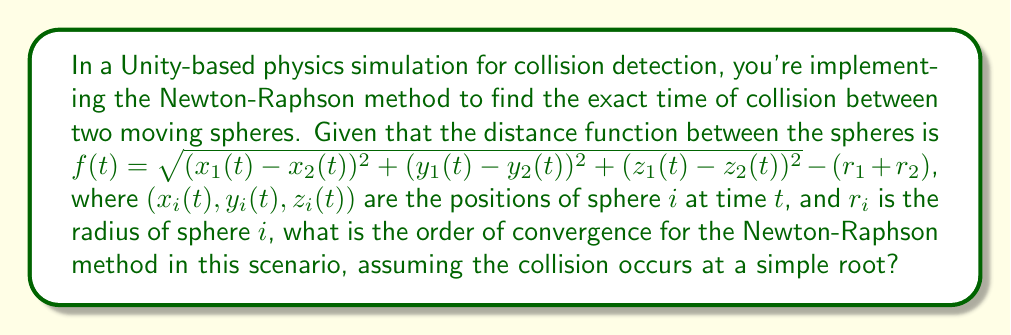Help me with this question. To determine the order of convergence for the Newton-Raphson method in this collision detection scenario, we need to consider the following steps:

1) The Newton-Raphson method is given by the iterative formula:

   $$t_{n+1} = t_n - \frac{f(t_n)}{f'(t_n)}$$

2) For a simple root (which we're assuming in this case), the Newton-Raphson method generally exhibits quadratic convergence. This means that the error in each iteration is proportional to the square of the error in the previous iteration.

3) Mathematically, we can express this as:

   $$|t_{n+1} - t^*| \approx C|t_n - t^*|^2$$

   where $t^*$ is the true solution (collision time) and $C$ is some constant.

4) The order of convergence, $p$, is defined by the relationship:

   $$\lim_{n \to \infty} \frac{|t_{n+1} - t^*|}{|t_n - t^*|^p} = C$$

5) For the Newton-Raphson method with a simple root, this limit exists with $p = 2$, which confirms quadratic convergence.

6) In our specific case with the distance function $f(t)$, we need to ensure that $f(t)$ is sufficiently smooth (at least twice continuously differentiable) near the root. Given that $f(t)$ involves square roots and squares of polynomial functions (assuming the position functions $x_i(t)$, $y_i(t)$, and $z_i(t)$ are polynomial), this condition is generally met.

7) Therefore, as long as the initial guess is sufficiently close to the true collision time and the collision occurs at a simple root of $f(t)$, the Newton-Raphson method will exhibit quadratic convergence in this collision detection scenario.
Answer: Quadratic (order 2) 